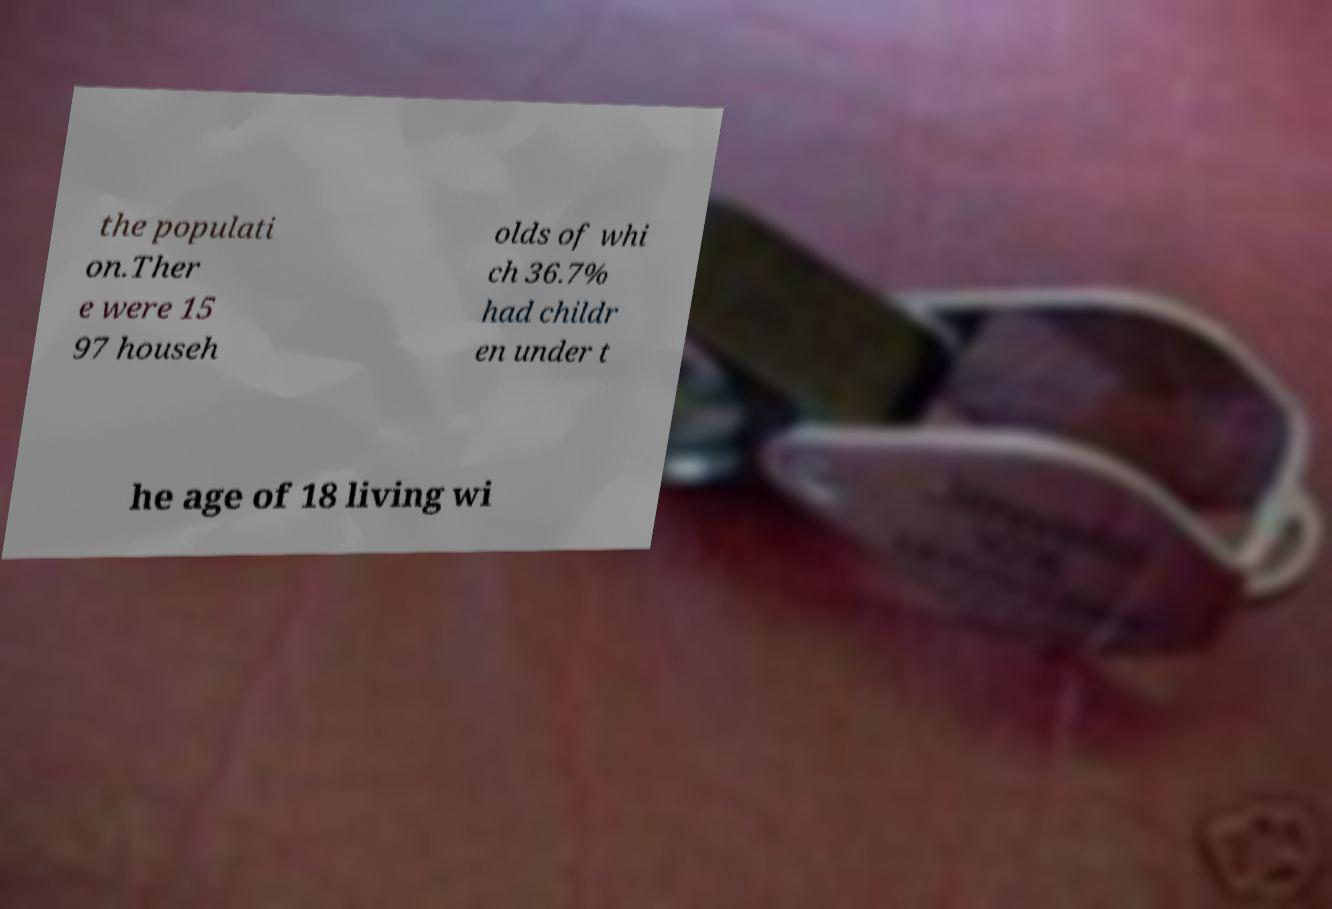Please identify and transcribe the text found in this image. the populati on.Ther e were 15 97 househ olds of whi ch 36.7% had childr en under t he age of 18 living wi 